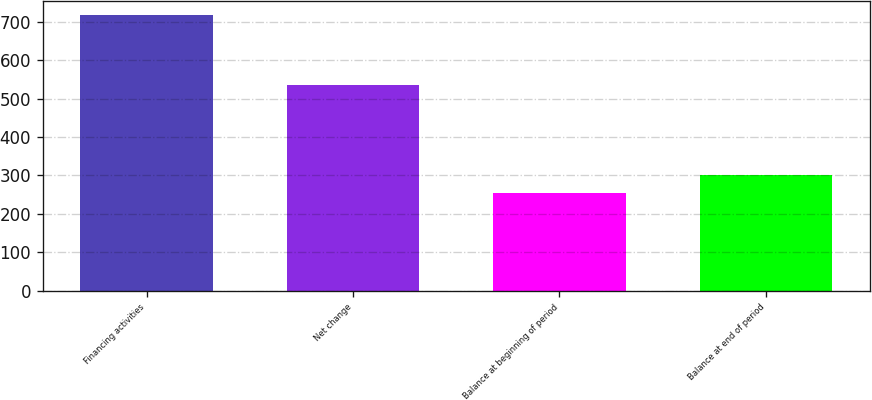Convert chart to OTSL. <chart><loc_0><loc_0><loc_500><loc_500><bar_chart><fcel>Financing activities<fcel>Net change<fcel>Balance at beginning of period<fcel>Balance at end of period<nl><fcel>717<fcel>534<fcel>254<fcel>300.3<nl></chart> 